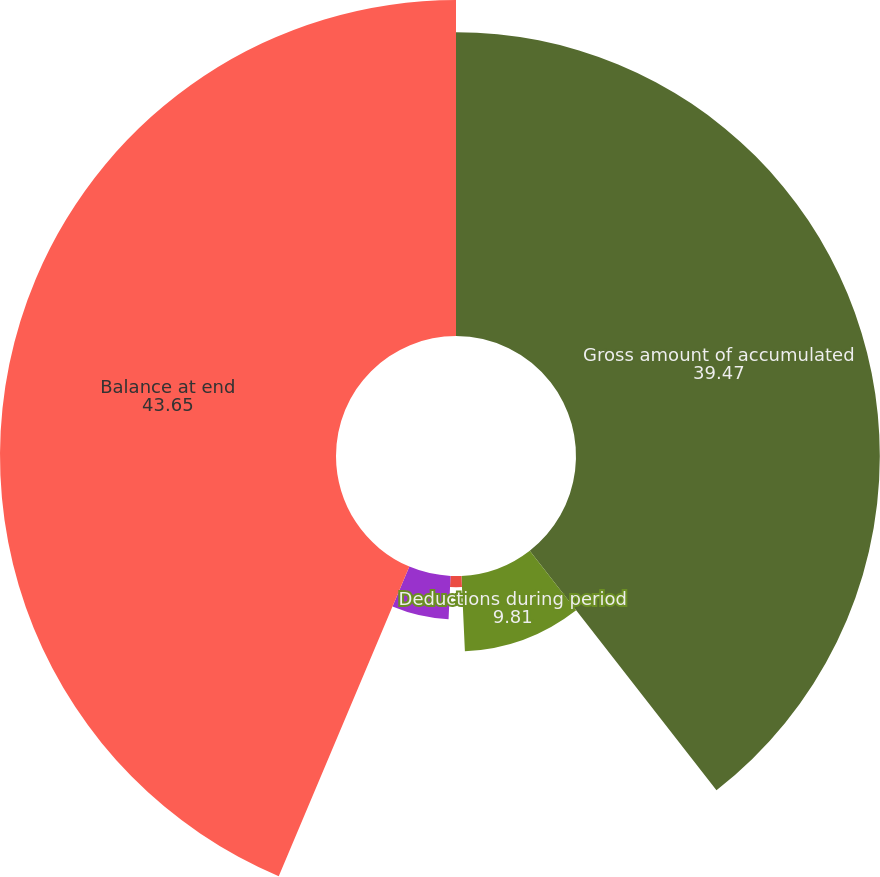<chart> <loc_0><loc_0><loc_500><loc_500><pie_chart><fcel>Gross amount of accumulated<fcel>Deductions during period<fcel>Amount of accumulated<fcel>Total deductions<fcel>Balance at end<nl><fcel>39.47%<fcel>9.81%<fcel>1.45%<fcel>5.63%<fcel>43.65%<nl></chart> 